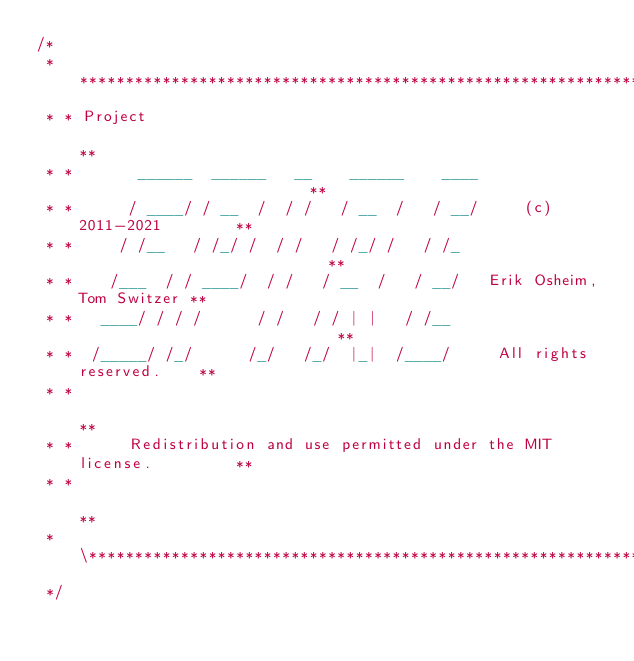<code> <loc_0><loc_0><loc_500><loc_500><_Scala_>/*
 * **********************************************************************\
 * * Project                                                              **
 * *       ______  ______   __    ______    ____                          **
 * *      / ____/ / __  /  / /   / __  /   / __/     (c) 2011-2021        **
 * *     / /__   / /_/ /  / /   / /_/ /   / /_                            **
 * *    /___  / / ____/  / /   / __  /   / __/   Erik Osheim, Tom Switzer **
 * *   ____/ / / /      / /   / / | |   / /__                             **
 * *  /_____/ /_/      /_/   /_/  |_|  /____/     All rights reserved.    **
 * *                                                                      **
 * *      Redistribution and use permitted under the MIT license.         **
 * *                                                                      **
 * \***********************************************************************
 */
</code> 